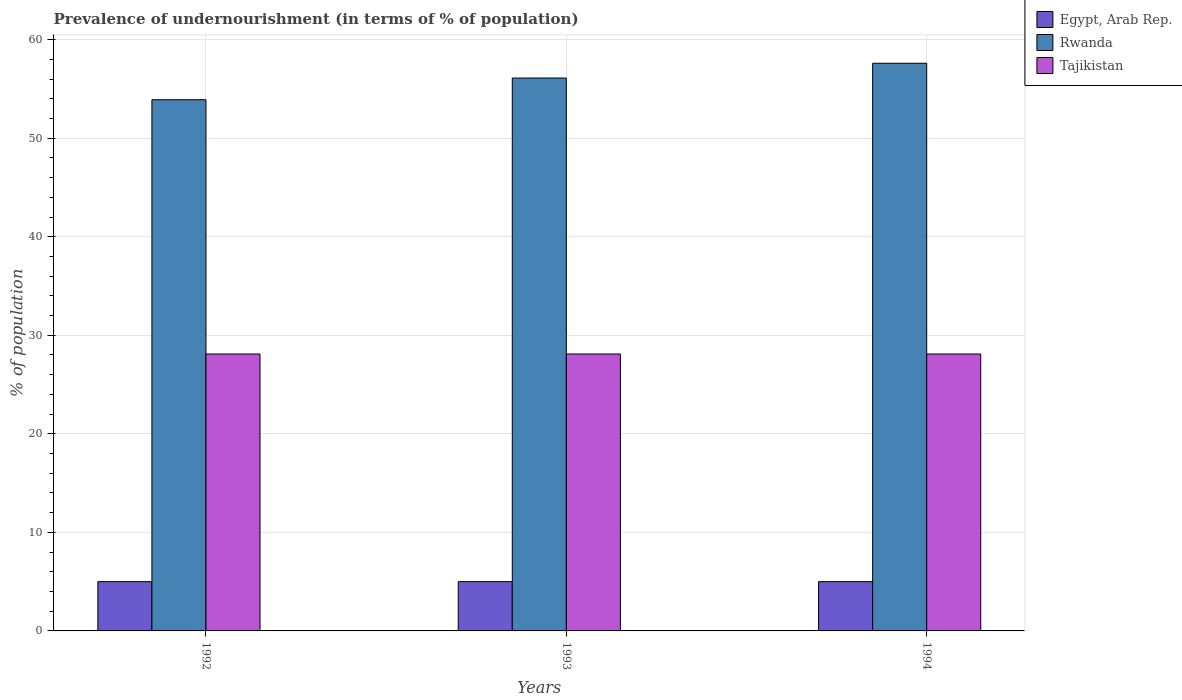How many different coloured bars are there?
Ensure brevity in your answer.  3. How many bars are there on the 1st tick from the right?
Your response must be concise. 3. In how many cases, is the number of bars for a given year not equal to the number of legend labels?
Give a very brief answer. 0. What is the percentage of undernourished population in Tajikistan in 1992?
Offer a terse response. 28.1. Across all years, what is the maximum percentage of undernourished population in Tajikistan?
Offer a very short reply. 28.1. Across all years, what is the minimum percentage of undernourished population in Rwanda?
Your answer should be very brief. 53.9. In which year was the percentage of undernourished population in Rwanda maximum?
Ensure brevity in your answer.  1994. In which year was the percentage of undernourished population in Rwanda minimum?
Ensure brevity in your answer.  1992. What is the total percentage of undernourished population in Egypt, Arab Rep. in the graph?
Your answer should be compact. 15. What is the difference between the percentage of undernourished population in Rwanda in 1993 and that in 1994?
Keep it short and to the point. -1.5. What is the difference between the percentage of undernourished population in Rwanda in 1992 and the percentage of undernourished population in Egypt, Arab Rep. in 1993?
Offer a very short reply. 48.9. What is the average percentage of undernourished population in Rwanda per year?
Ensure brevity in your answer.  55.87. In the year 1992, what is the difference between the percentage of undernourished population in Egypt, Arab Rep. and percentage of undernourished population in Rwanda?
Offer a very short reply. -48.9. What is the ratio of the percentage of undernourished population in Egypt, Arab Rep. in 1992 to that in 1994?
Offer a terse response. 1. Is the difference between the percentage of undernourished population in Egypt, Arab Rep. in 1992 and 1993 greater than the difference between the percentage of undernourished population in Rwanda in 1992 and 1993?
Provide a short and direct response. Yes. What is the difference between the highest and the second highest percentage of undernourished population in Tajikistan?
Ensure brevity in your answer.  0. What is the difference between the highest and the lowest percentage of undernourished population in Egypt, Arab Rep.?
Your response must be concise. 0. Is the sum of the percentage of undernourished population in Tajikistan in 1993 and 1994 greater than the maximum percentage of undernourished population in Rwanda across all years?
Ensure brevity in your answer.  No. What does the 2nd bar from the left in 1992 represents?
Give a very brief answer. Rwanda. What does the 3rd bar from the right in 1992 represents?
Keep it short and to the point. Egypt, Arab Rep. Is it the case that in every year, the sum of the percentage of undernourished population in Tajikistan and percentage of undernourished population in Egypt, Arab Rep. is greater than the percentage of undernourished population in Rwanda?
Your response must be concise. No. How many bars are there?
Offer a very short reply. 9. Are all the bars in the graph horizontal?
Make the answer very short. No. Does the graph contain grids?
Ensure brevity in your answer.  Yes. Where does the legend appear in the graph?
Your answer should be compact. Top right. What is the title of the graph?
Your answer should be very brief. Prevalence of undernourishment (in terms of % of population). Does "Trinidad and Tobago" appear as one of the legend labels in the graph?
Offer a terse response. No. What is the label or title of the Y-axis?
Make the answer very short. % of population. What is the % of population in Egypt, Arab Rep. in 1992?
Your answer should be very brief. 5. What is the % of population of Rwanda in 1992?
Provide a short and direct response. 53.9. What is the % of population of Tajikistan in 1992?
Your response must be concise. 28.1. What is the % of population of Egypt, Arab Rep. in 1993?
Offer a terse response. 5. What is the % of population in Rwanda in 1993?
Offer a terse response. 56.1. What is the % of population in Tajikistan in 1993?
Offer a terse response. 28.1. What is the % of population of Egypt, Arab Rep. in 1994?
Your answer should be very brief. 5. What is the % of population in Rwanda in 1994?
Give a very brief answer. 57.6. What is the % of population of Tajikistan in 1994?
Your answer should be compact. 28.1. Across all years, what is the maximum % of population in Egypt, Arab Rep.?
Your answer should be compact. 5. Across all years, what is the maximum % of population of Rwanda?
Your answer should be very brief. 57.6. Across all years, what is the maximum % of population in Tajikistan?
Provide a short and direct response. 28.1. Across all years, what is the minimum % of population of Egypt, Arab Rep.?
Provide a succinct answer. 5. Across all years, what is the minimum % of population of Rwanda?
Make the answer very short. 53.9. Across all years, what is the minimum % of population of Tajikistan?
Ensure brevity in your answer.  28.1. What is the total % of population of Egypt, Arab Rep. in the graph?
Offer a terse response. 15. What is the total % of population in Rwanda in the graph?
Give a very brief answer. 167.6. What is the total % of population in Tajikistan in the graph?
Offer a terse response. 84.3. What is the difference between the % of population of Egypt, Arab Rep. in 1992 and that in 1993?
Your answer should be very brief. 0. What is the difference between the % of population in Egypt, Arab Rep. in 1992 and that in 1994?
Make the answer very short. 0. What is the difference between the % of population in Egypt, Arab Rep. in 1992 and the % of population in Rwanda in 1993?
Your answer should be very brief. -51.1. What is the difference between the % of population in Egypt, Arab Rep. in 1992 and the % of population in Tajikistan in 1993?
Keep it short and to the point. -23.1. What is the difference between the % of population in Rwanda in 1992 and the % of population in Tajikistan in 1993?
Give a very brief answer. 25.8. What is the difference between the % of population in Egypt, Arab Rep. in 1992 and the % of population in Rwanda in 1994?
Give a very brief answer. -52.6. What is the difference between the % of population in Egypt, Arab Rep. in 1992 and the % of population in Tajikistan in 1994?
Give a very brief answer. -23.1. What is the difference between the % of population of Rwanda in 1992 and the % of population of Tajikistan in 1994?
Offer a terse response. 25.8. What is the difference between the % of population in Egypt, Arab Rep. in 1993 and the % of population in Rwanda in 1994?
Your answer should be compact. -52.6. What is the difference between the % of population of Egypt, Arab Rep. in 1993 and the % of population of Tajikistan in 1994?
Your response must be concise. -23.1. What is the average % of population of Egypt, Arab Rep. per year?
Give a very brief answer. 5. What is the average % of population of Rwanda per year?
Provide a succinct answer. 55.87. What is the average % of population in Tajikistan per year?
Make the answer very short. 28.1. In the year 1992, what is the difference between the % of population in Egypt, Arab Rep. and % of population in Rwanda?
Your answer should be very brief. -48.9. In the year 1992, what is the difference between the % of population in Egypt, Arab Rep. and % of population in Tajikistan?
Offer a very short reply. -23.1. In the year 1992, what is the difference between the % of population of Rwanda and % of population of Tajikistan?
Make the answer very short. 25.8. In the year 1993, what is the difference between the % of population of Egypt, Arab Rep. and % of population of Rwanda?
Keep it short and to the point. -51.1. In the year 1993, what is the difference between the % of population in Egypt, Arab Rep. and % of population in Tajikistan?
Provide a short and direct response. -23.1. In the year 1994, what is the difference between the % of population of Egypt, Arab Rep. and % of population of Rwanda?
Your answer should be very brief. -52.6. In the year 1994, what is the difference between the % of population of Egypt, Arab Rep. and % of population of Tajikistan?
Give a very brief answer. -23.1. In the year 1994, what is the difference between the % of population in Rwanda and % of population in Tajikistan?
Keep it short and to the point. 29.5. What is the ratio of the % of population of Rwanda in 1992 to that in 1993?
Offer a very short reply. 0.96. What is the ratio of the % of population of Tajikistan in 1992 to that in 1993?
Your answer should be very brief. 1. What is the ratio of the % of population in Rwanda in 1992 to that in 1994?
Your answer should be very brief. 0.94. What is the ratio of the % of population of Tajikistan in 1992 to that in 1994?
Ensure brevity in your answer.  1. What is the ratio of the % of population of Egypt, Arab Rep. in 1993 to that in 1994?
Ensure brevity in your answer.  1. What is the ratio of the % of population of Rwanda in 1993 to that in 1994?
Provide a succinct answer. 0.97. What is the ratio of the % of population in Tajikistan in 1993 to that in 1994?
Provide a succinct answer. 1. What is the difference between the highest and the lowest % of population of Egypt, Arab Rep.?
Your answer should be very brief. 0. What is the difference between the highest and the lowest % of population in Rwanda?
Provide a succinct answer. 3.7. 